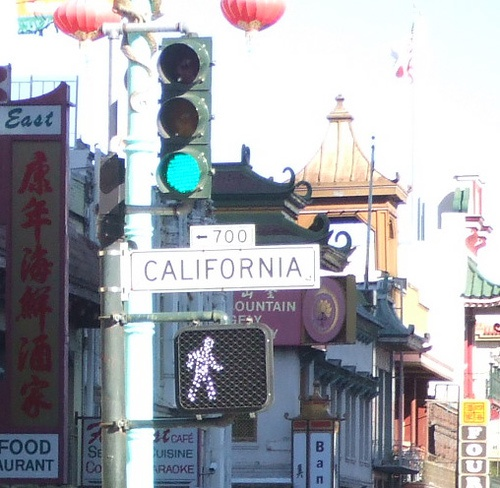Describe the objects in this image and their specific colors. I can see a traffic light in white, black, darkgray, cyan, and blue tones in this image. 